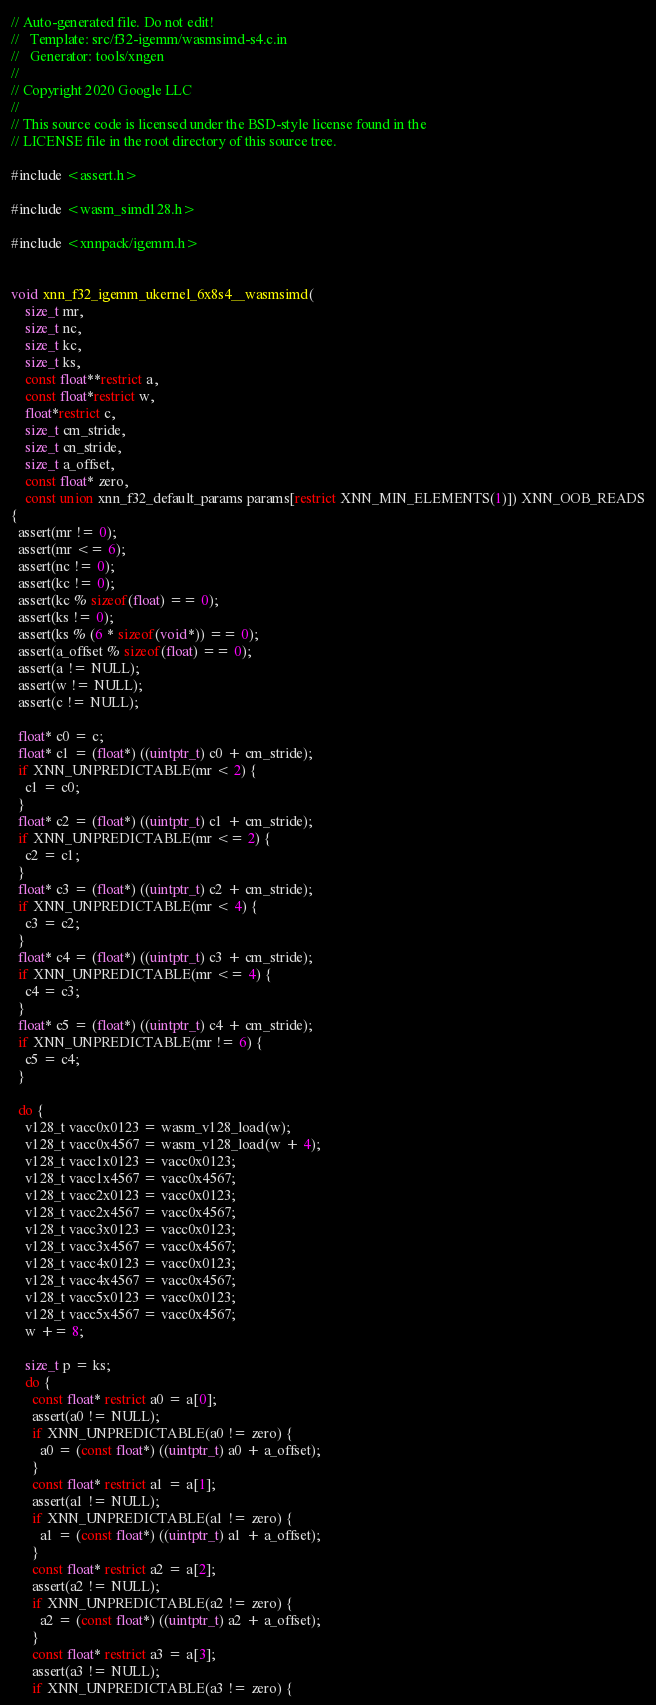<code> <loc_0><loc_0><loc_500><loc_500><_C_>// Auto-generated file. Do not edit!
//   Template: src/f32-igemm/wasmsimd-s4.c.in
//   Generator: tools/xngen
//
// Copyright 2020 Google LLC
//
// This source code is licensed under the BSD-style license found in the
// LICENSE file in the root directory of this source tree.

#include <assert.h>

#include <wasm_simd128.h>

#include <xnnpack/igemm.h>


void xnn_f32_igemm_ukernel_6x8s4__wasmsimd(
    size_t mr,
    size_t nc,
    size_t kc,
    size_t ks,
    const float**restrict a,
    const float*restrict w,
    float*restrict c,
    size_t cm_stride,
    size_t cn_stride,
    size_t a_offset,
    const float* zero,
    const union xnn_f32_default_params params[restrict XNN_MIN_ELEMENTS(1)]) XNN_OOB_READS
{
  assert(mr != 0);
  assert(mr <= 6);
  assert(nc != 0);
  assert(kc != 0);
  assert(kc % sizeof(float) == 0);
  assert(ks != 0);
  assert(ks % (6 * sizeof(void*)) == 0);
  assert(a_offset % sizeof(float) == 0);
  assert(a != NULL);
  assert(w != NULL);
  assert(c != NULL);

  float* c0 = c;
  float* c1 = (float*) ((uintptr_t) c0 + cm_stride);
  if XNN_UNPREDICTABLE(mr < 2) {
    c1 = c0;
  }
  float* c2 = (float*) ((uintptr_t) c1 + cm_stride);
  if XNN_UNPREDICTABLE(mr <= 2) {
    c2 = c1;
  }
  float* c3 = (float*) ((uintptr_t) c2 + cm_stride);
  if XNN_UNPREDICTABLE(mr < 4) {
    c3 = c2;
  }
  float* c4 = (float*) ((uintptr_t) c3 + cm_stride);
  if XNN_UNPREDICTABLE(mr <= 4) {
    c4 = c3;
  }
  float* c5 = (float*) ((uintptr_t) c4 + cm_stride);
  if XNN_UNPREDICTABLE(mr != 6) {
    c5 = c4;
  }

  do {
    v128_t vacc0x0123 = wasm_v128_load(w);
    v128_t vacc0x4567 = wasm_v128_load(w + 4);
    v128_t vacc1x0123 = vacc0x0123;
    v128_t vacc1x4567 = vacc0x4567;
    v128_t vacc2x0123 = vacc0x0123;
    v128_t vacc2x4567 = vacc0x4567;
    v128_t vacc3x0123 = vacc0x0123;
    v128_t vacc3x4567 = vacc0x4567;
    v128_t vacc4x0123 = vacc0x0123;
    v128_t vacc4x4567 = vacc0x4567;
    v128_t vacc5x0123 = vacc0x0123;
    v128_t vacc5x4567 = vacc0x4567;
    w += 8;

    size_t p = ks;
    do {
      const float* restrict a0 = a[0];
      assert(a0 != NULL);
      if XNN_UNPREDICTABLE(a0 != zero) {
        a0 = (const float*) ((uintptr_t) a0 + a_offset);
      }
      const float* restrict a1 = a[1];
      assert(a1 != NULL);
      if XNN_UNPREDICTABLE(a1 != zero) {
        a1 = (const float*) ((uintptr_t) a1 + a_offset);
      }
      const float* restrict a2 = a[2];
      assert(a2 != NULL);
      if XNN_UNPREDICTABLE(a2 != zero) {
        a2 = (const float*) ((uintptr_t) a2 + a_offset);
      }
      const float* restrict a3 = a[3];
      assert(a3 != NULL);
      if XNN_UNPREDICTABLE(a3 != zero) {</code> 